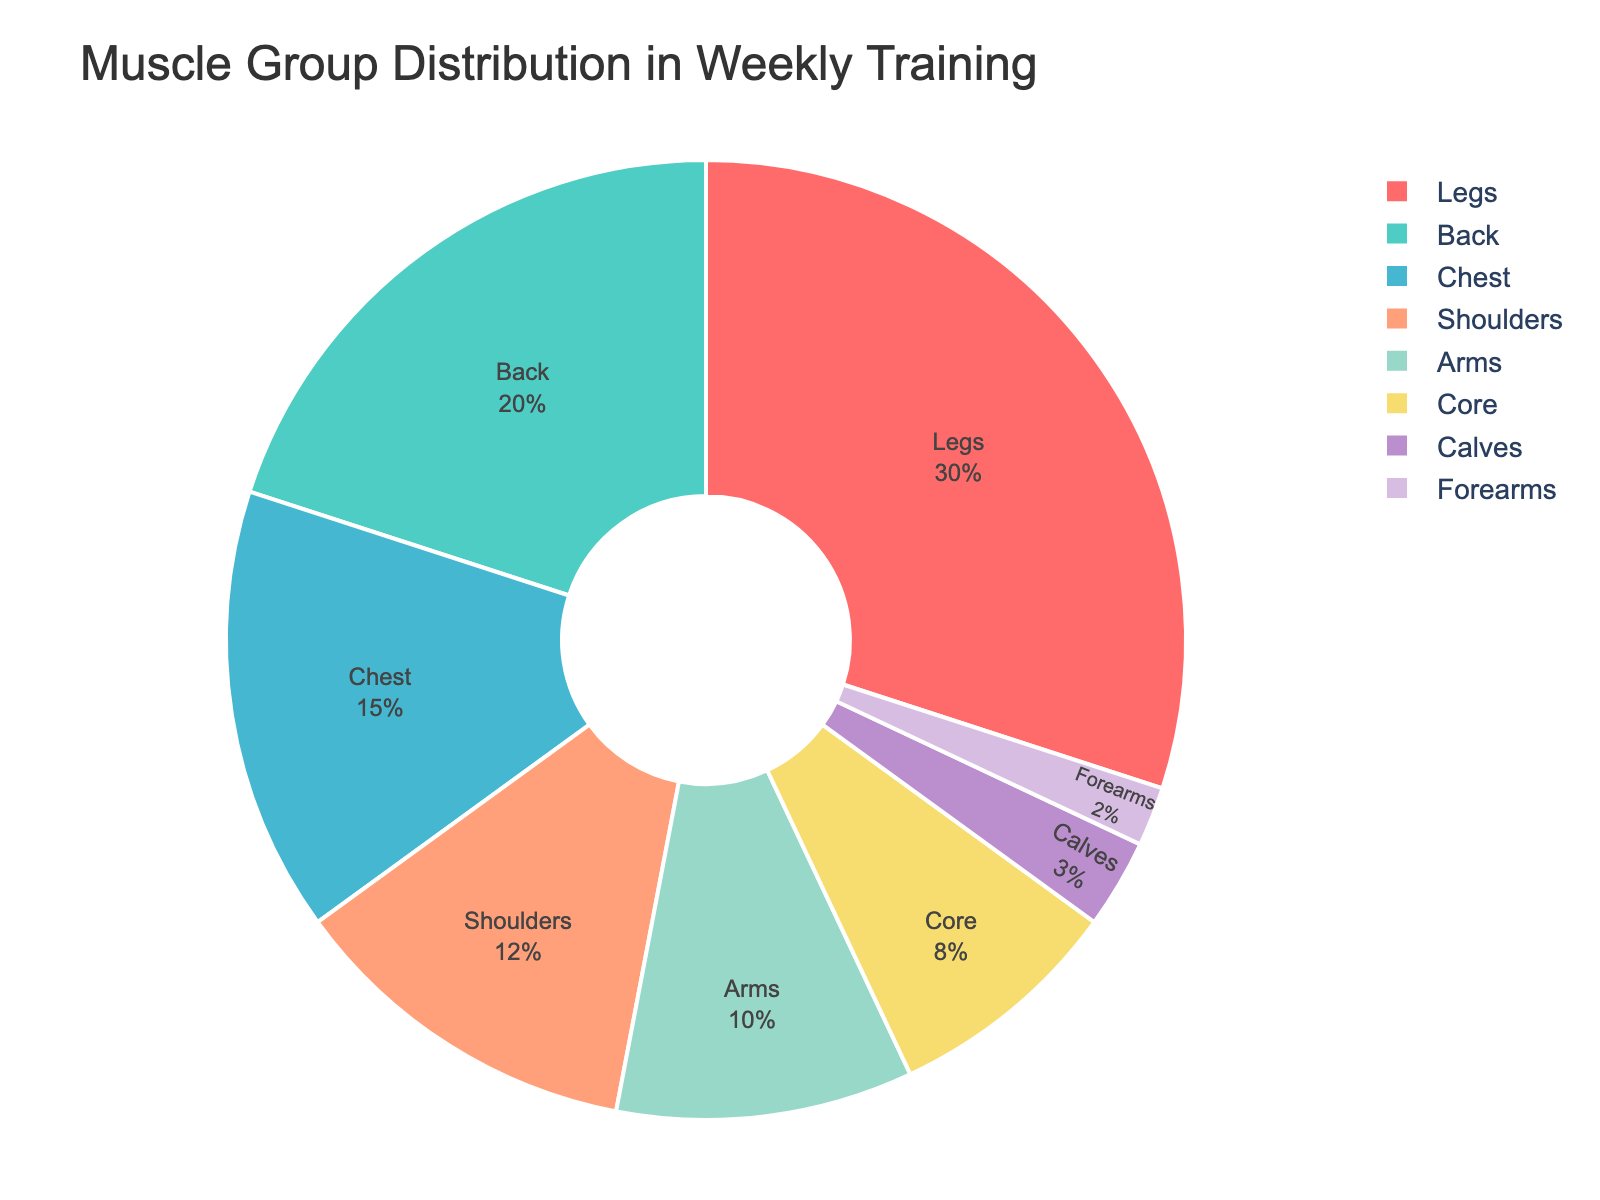Which muscle group is targeted the most in the weekly training routine? The chart shows different muscle groups with their corresponding percentage shares. To see which one has the highest percentage, look for the largest section of the pie chart. The largest segment is represented by "Legs" at 30%.
Answer: Legs Which muscle groups combined account for at least 50% of the total training? Adding the percentages, Legs (30%) + Back (20%) = 50%, so "Legs" and "Back" together cover at least 50% of the total training time.
Answer: Legs and Back How much more percentage is dedicated to training Back compared to Arms? The Back has 20% while the Arms have 10%. Subtract the smaller percentage from the larger one: 20% - 10% = 10%.
Answer: 10% Which muscle group has the lowest percentage share in the weekly training? The smallest portion of the pie chart corresponds to the muscle group "Forearms" with a percentage of 2%.
Answer: Forearms What is the combined percentage of training dedicated to Chest and Shoulders? Sum the percentages for Chest and Shoulders: 15% (Chest) + 12% (Shoulders) = 27%.
Answer: 27% Compare the percentage of training dedicated to Legs and Core. Which one is greater and by how much? Legs have 30% and Core has 8%. Subtract the Core percentage from the Legs percentage: 30% - 8% = 22%. Therefore, Legs have 22% more training time.
Answer: Legs by 22% What fraction of the weekly training is allocated to both Legs and Arms combined? First, sum the percentages for Legs and Arms: 30% (Legs) + 10% (Arms) = 40%. Then, convert this to a fraction of the total 100%, which is 40/100 or simplified to 2/5.
Answer: 2/5 Which muscle group shares similar percentage values closely related to Shoulders in training time? The chart shows that Shoulders have 12%, and the closest percentages are Chest with 15% and Arms with 10%. Between these, the Arms are closer to the Shoulders at a 2% difference.
Answer: Arms What is the average percentage dedicated to Chest, Arms, and Core in the weekly training routine? Add up the percentages for these three muscle groups and then divide by 3: (15% + 10% + 8%) / 3 = 33% / 3 = 11%.
Answer: 11% How does the percentage of training time for Calves compare to that for the Core? Calves take 3% of the training time while Core takes 8%. To find the difference, subtract 3% from 8%, which is 8% - 3% = 5%. Therefore, there is a greater focus on Core by 5%.
Answer: Core by 5% 